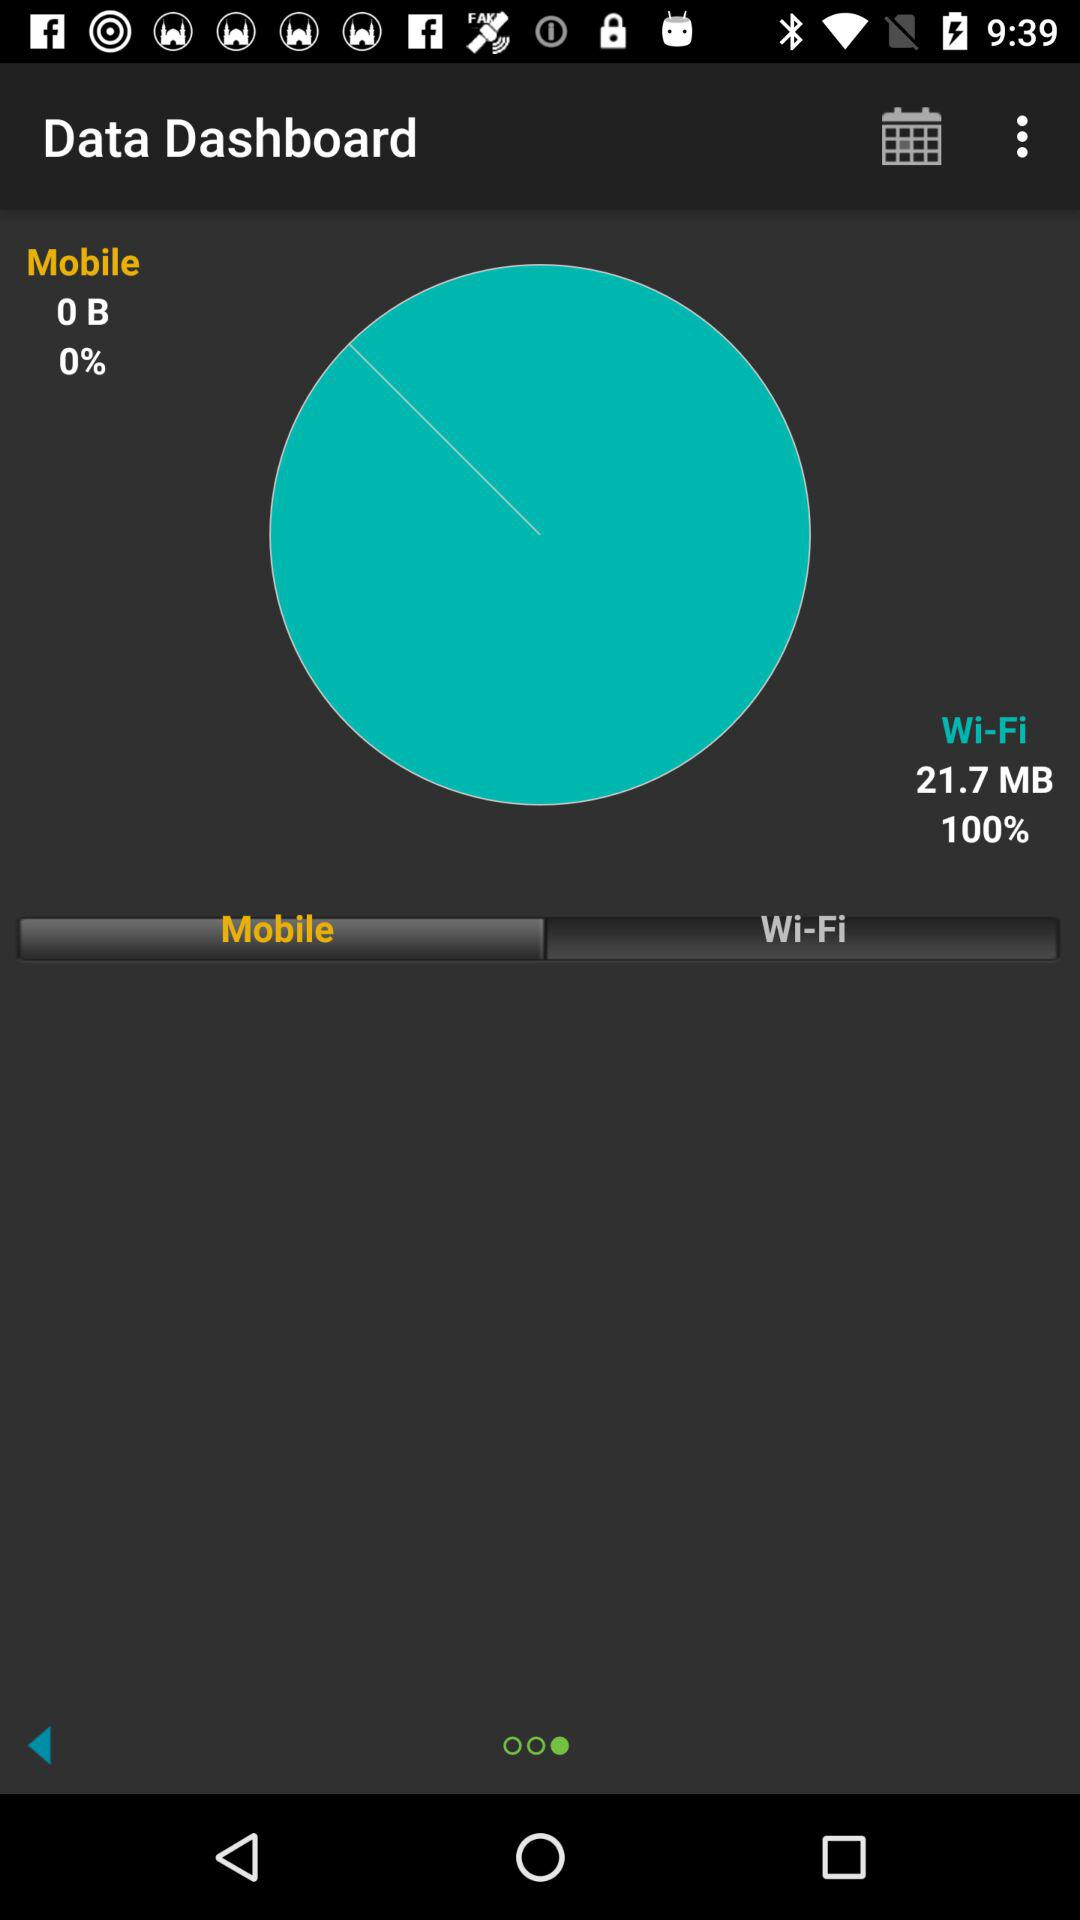What is the difference between the amount of data used and the amount of data available?
Answer the question using a single word or phrase. 21.7 MB 